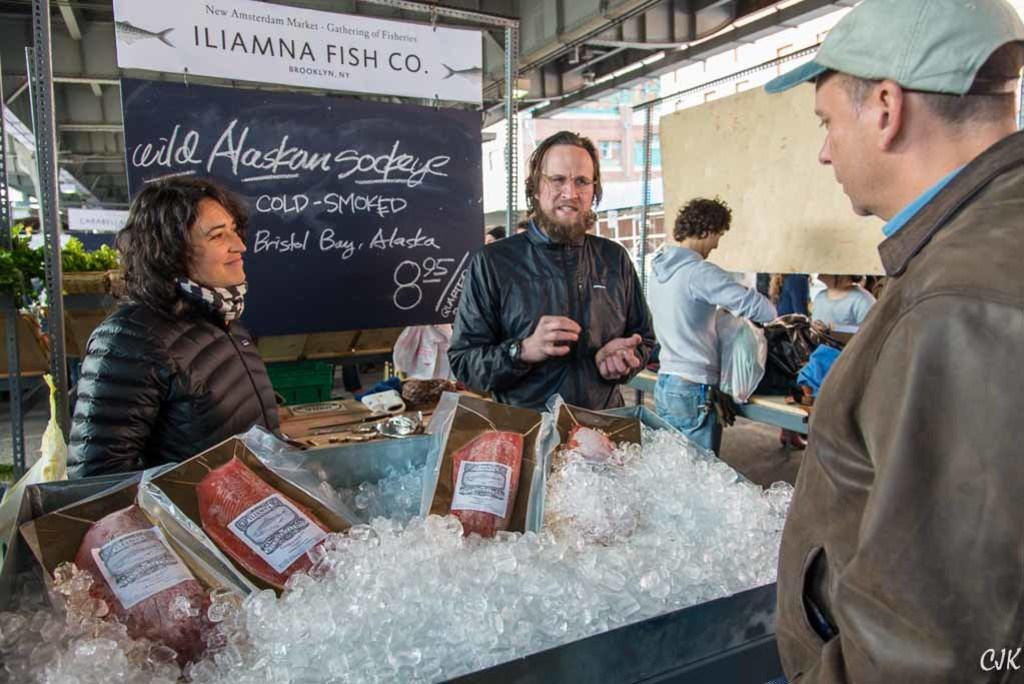How would you summarize this image in a sentence or two? It is a fish market,inside the fish market the fishes are kept on the ice and there is a woman and man are standing in front of shopkeeper and behind them on the board the prices of the fish are mentioned and in the background there is a building. 